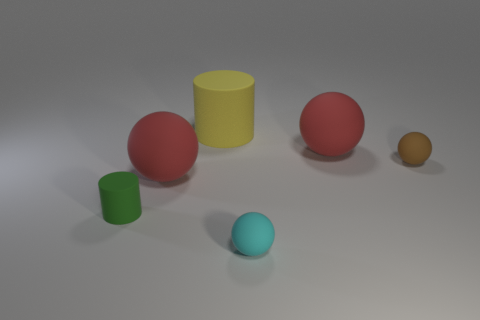Are there any rubber balls right of the small object in front of the green cylinder to the left of the big yellow cylinder?
Offer a terse response. Yes. What number of small things are rubber cylinders or brown objects?
Ensure brevity in your answer.  2. What color is the matte cylinder that is the same size as the cyan thing?
Your response must be concise. Green. How many tiny cyan rubber objects are in front of the tiny matte cylinder?
Your answer should be compact. 1. Is there a purple cylinder made of the same material as the large yellow cylinder?
Your response must be concise. No. There is a large matte ball that is on the right side of the cyan rubber sphere; what color is it?
Your answer should be compact. Red. Are there an equal number of yellow rubber objects that are in front of the green matte cylinder and big objects that are to the right of the small brown object?
Keep it short and to the point. Yes. How many objects are big blue metal spheres or big rubber spheres in front of the brown sphere?
Your response must be concise. 1. What is the size of the brown thing that is the same material as the big cylinder?
Provide a succinct answer. Small. Are there more rubber objects that are behind the small green rubber thing than tiny brown things?
Provide a succinct answer. Yes. 